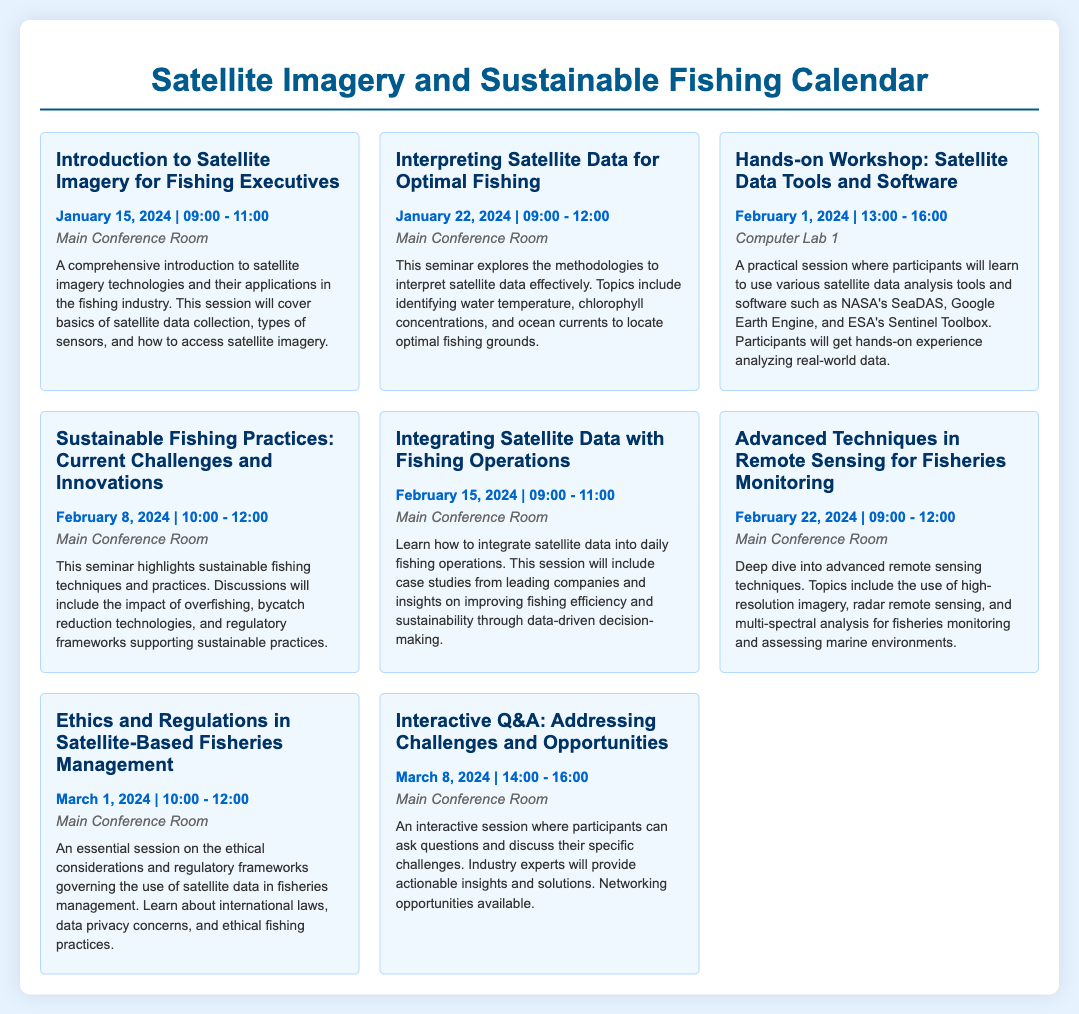What is the first seminar title? The first seminar title is located at the top of the calendar.
Answer: Introduction to Satellite Imagery for Fishing Executives When is the workshop on satellite data tools? The date of the workshop can be found by looking for that specific event in the calendar.
Answer: February 1, 2024 How long is the seminar on sustainable fishing practices? The duration can be inferred from the start and end times mentioned in the event details.
Answer: 2 hours Which room hosts the "Interpreting Satellite Data for Optimal Fishing" seminar? The location of the seminar is stated in the event description next to that title.
Answer: Main Conference Room What are the main topics covered in the advanced techniques seminar? The main topics can be determined by analyzing the event description for that seminar.
Answer: High-resolution imagery, radar remote sensing, multi-spectral analysis How many events are scheduled in January 2024? The number of events can be counted by looking at all the events listed for that month.
Answer: 2 events What is the date of the ethics and regulations seminar? The specific date can be located in the details of the corresponding event.
Answer: March 1, 2024 How many hours is the interactive Q&A session scheduled for? This can be calculated based on the given time frame for that event.
Answer: 2 hours 